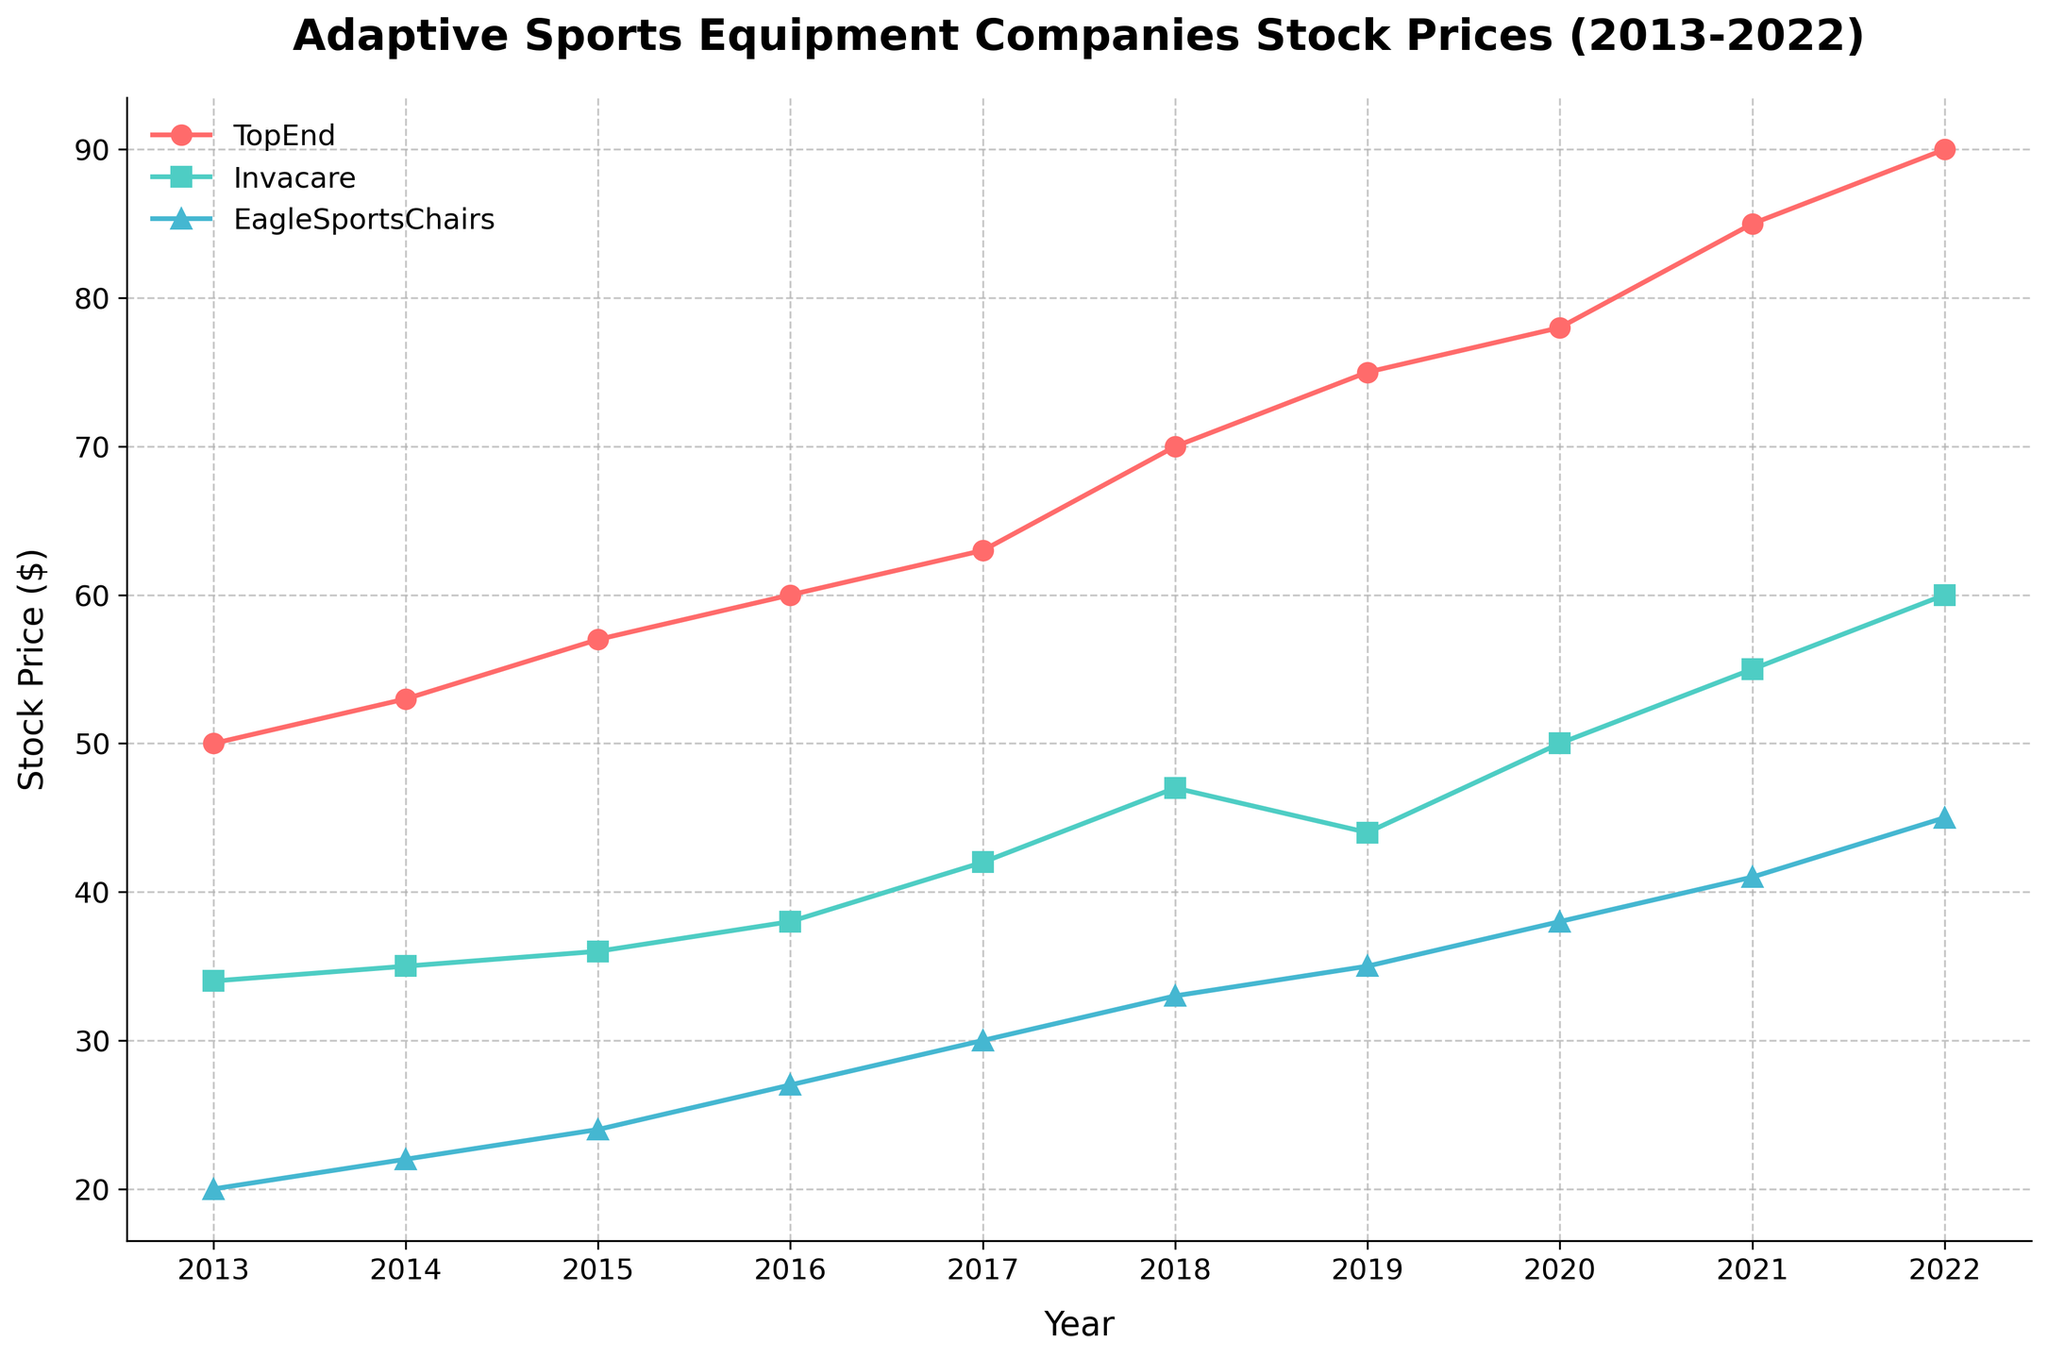What is the title of the figure? The title is usually found at the top of the figure and typically describes what the figure is about.
Answer: Adaptive Sports Equipment Companies Stock Prices (2013-2022) How many companies are represented in the figure? Check the legend or the number of unique lines in different colors and markers on the plot.
Answer: 3 Which company had the highest stock price at the end of the period (2022-01-01)? Follow the lines to the endpoint on the right and compare the stock prices.
Answer: TopEnd What is the stock price of Invacare in 2018? Follow the Invacare line to the point labeled 2018 on the x-axis and read the corresponding y-axis value.
Answer: $47 Which company had the steepest increase in stock price between 2013 and 2022? Compare the slopes of the lines from 2013 to 2022; the steepest slope indicates the largest increase.
Answer: TopEnd What is the average stock price of EagleSportsChairs over the decade? Add the stock prices for EagleSportsChairs from 2013 to 2022 and divide by the number of years.
Answer: (20+22+24+27+30+33+35+38+41+45)/10 = 31.5 Between which years did TopEnd see the largest increase in stock price? Compare the differences in stock prices for TopEnd year over year and identify the largest change.
Answer: 2020 to 2021 Was there any year when Invacare had a stock price decline compared to the previous year? If so, when? Check if any point on the Invacare line is lower than the previous point.
Answer: Yes, 2018 to 2019 What is the stock price difference between TopEnd and EagleSportsChairs in 2020? Find the stock prices of both companies in 2020 and subtract the smaller value from the larger value.
Answer: 78 - 38 = 40 